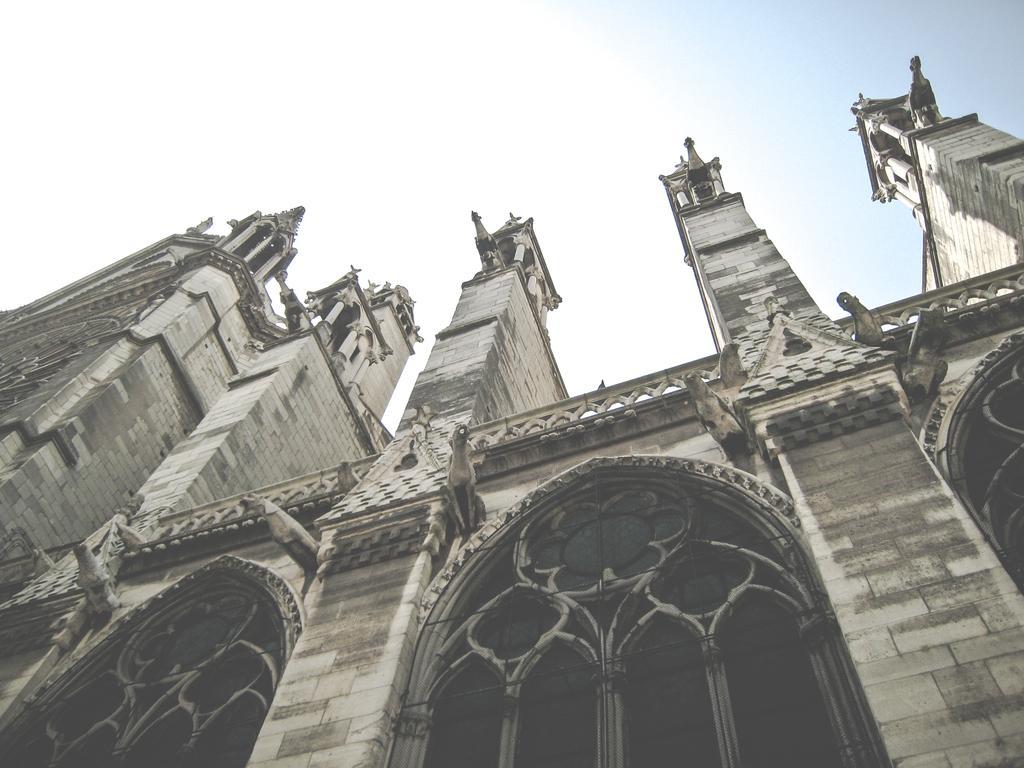In one or two sentences, can you explain what this image depicts? In this picture we can see a building, there is the sky at the top of the picture. 